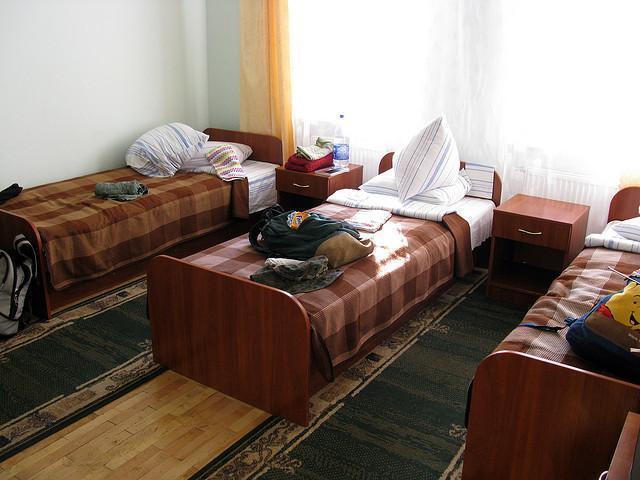What color is the face of the cartoon character on the backpack on the far right bed?
Pick the right solution, then justify: 'Answer: answer
Rationale: rationale.'
Options: Orange, blue, brown, yellow. Answer: yellow.
Rationale: The character in the bag is yellow. 